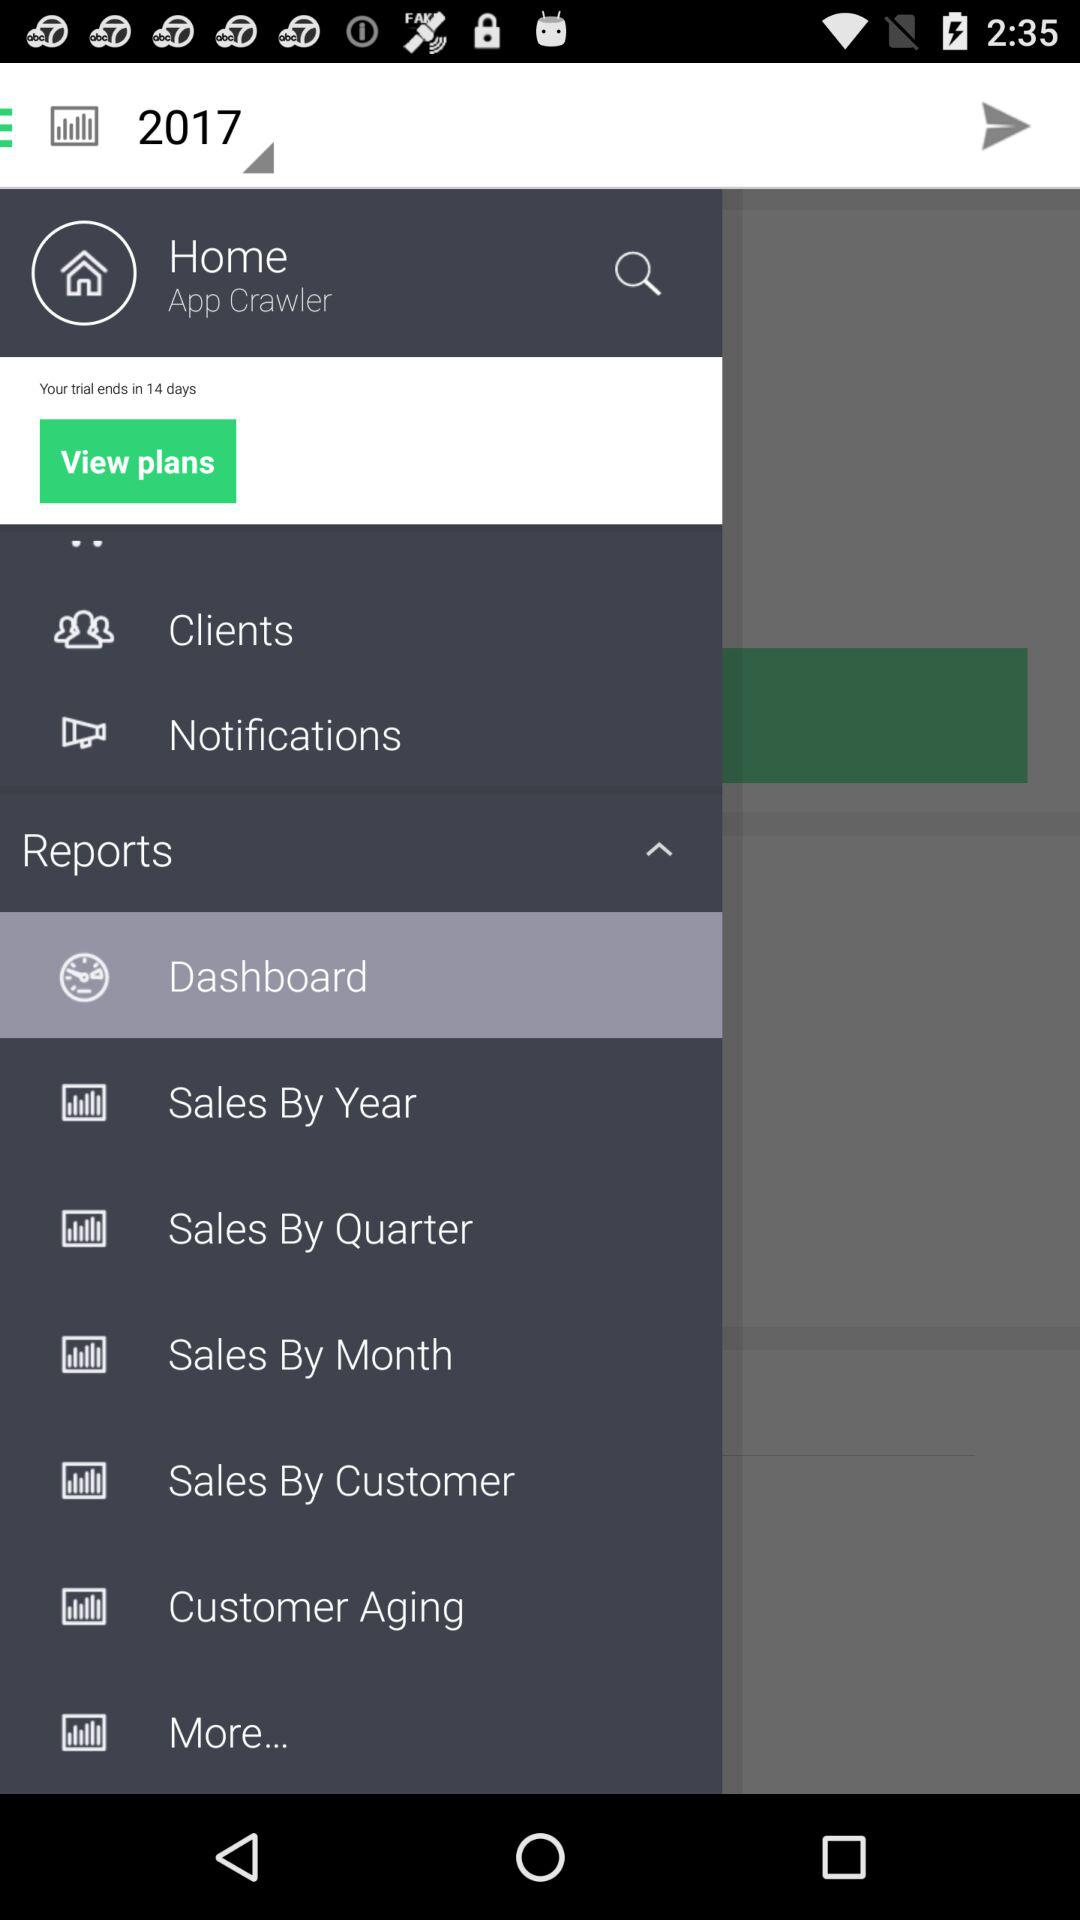What year has been displayed? The displayed year is 2017. 